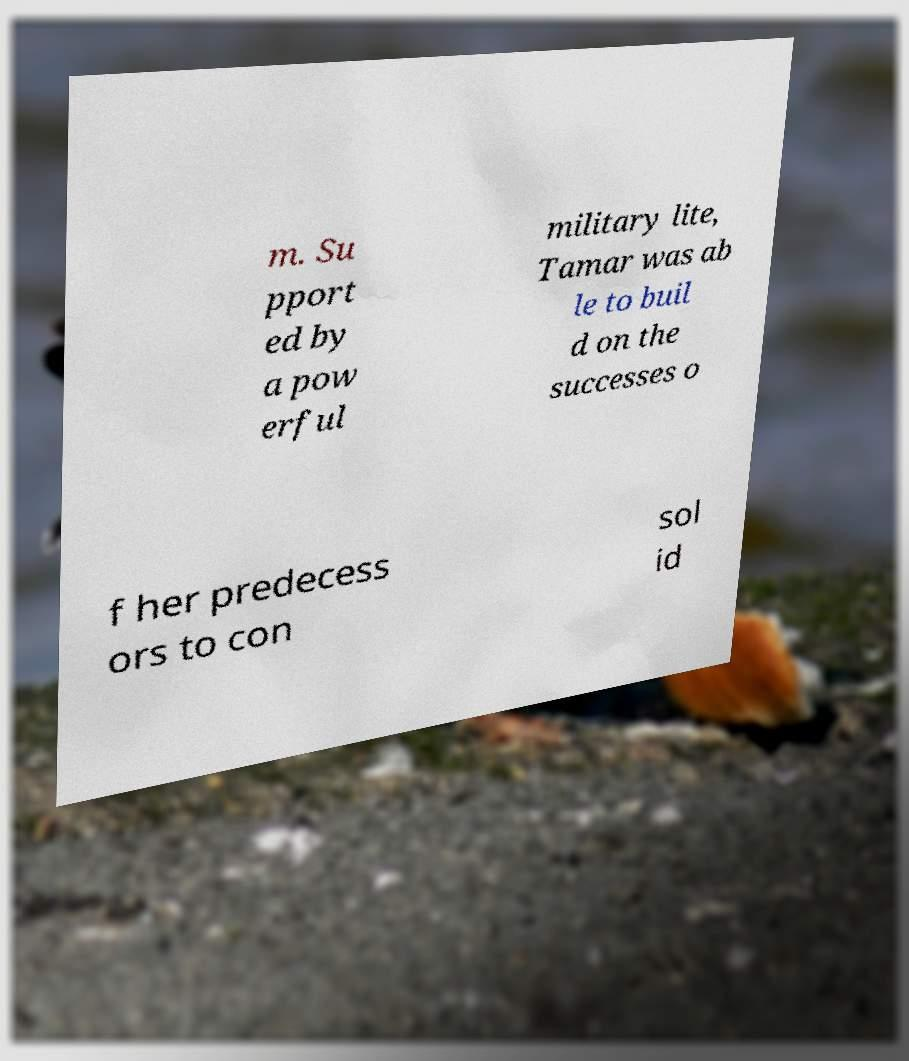Can you read and provide the text displayed in the image?This photo seems to have some interesting text. Can you extract and type it out for me? m. Su pport ed by a pow erful military lite, Tamar was ab le to buil d on the successes o f her predecess ors to con sol id 